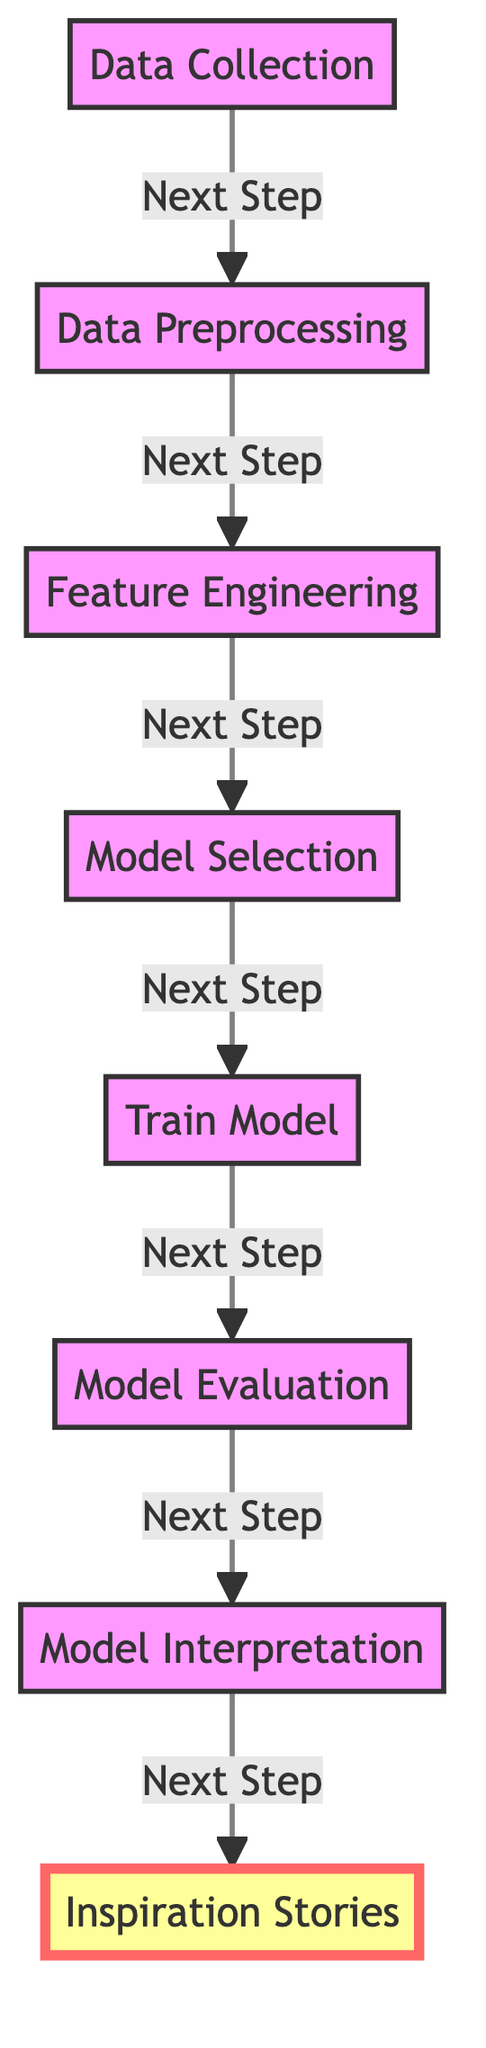What is the first step in the process? The diagram indicates that the first step is "Data Collection," shown as node A.
Answer: Data Collection How many nodes are in the diagram? The diagram presents a total of eight distinct nodes representing various steps in the machine learning process.
Answer: Eight What is the last step before "Inspiration Stories"? The step immediately preceding "Inspiration Stories," which is node H, is "Model Interpretation," represented as node G.
Answer: Model Interpretation What is the relationship between "Model Evaluation" and "Train Model"? "Model Evaluation" (node F) leads directly to "Train Model" (node E), indicating a sequential relationship where evaluation follows training.
Answer: Sequential Identify the step that focuses on selecting a machine learning algorithm. The step dedicated to selecting a machine learning algorithm is "Model Selection," located as node D in the diagram.
Answer: Model Selection How many steps are there between "Data Preprocessing" and "Model Interpretation"? There are three steps between "Data Preprocessing" (node B) and "Model Interpretation" (node G): Feature Engineering (C), Model Selection (D), and Train Model (E).
Answer: Three Which step involves creating features from the collected data? The step responsible for creating features from the collected data is "Feature Engineering," represented as node C.
Answer: Feature Engineering Why is "Model Evaluation" crucial in this process? "Model Evaluation" (node F) is crucial as it assesses the performance of the trained model, ensuring its effectiveness before further steps are taken, such as interpretation.
Answer: Assess performance 